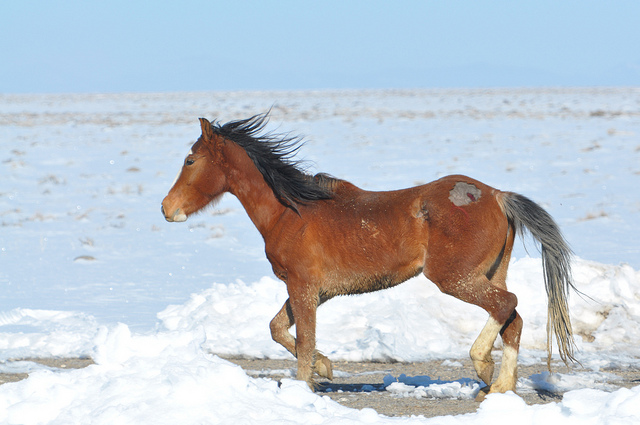<image>Why does the horse have a bald patch on its hindquarters? I don't know why the horse has a bald patch on its hindquarters. It could be due to old age, sickness or injury. Why does the horse have a bald patch on its hindquarters? I don't know why the horse has a bald patch on its hindquarters. It could be due to old age, illness, or injury. 